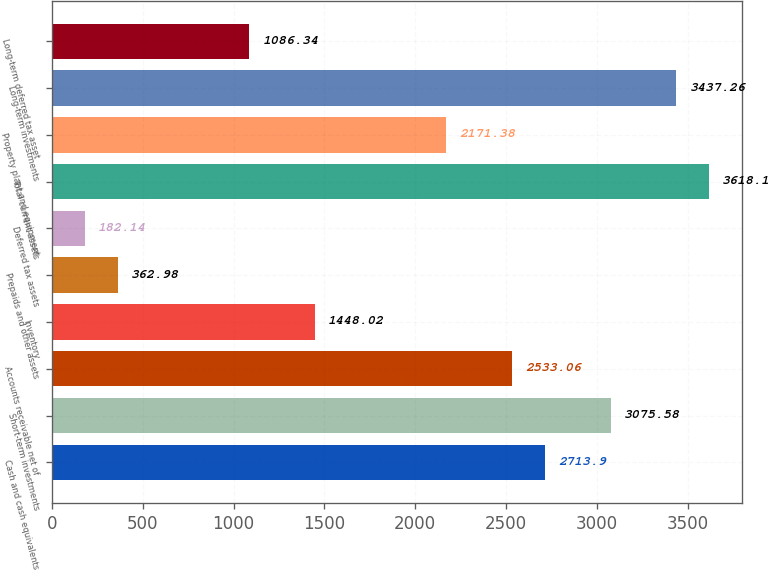<chart> <loc_0><loc_0><loc_500><loc_500><bar_chart><fcel>Cash and cash equivalents<fcel>Short-term investments<fcel>Accounts receivable net of<fcel>Inventory<fcel>Prepaids and other assets<fcel>Deferred tax assets<fcel>Total current assets<fcel>Property plant and equipment<fcel>Long-term investments<fcel>Long-term deferred tax asset<nl><fcel>2713.9<fcel>3075.58<fcel>2533.06<fcel>1448.02<fcel>362.98<fcel>182.14<fcel>3618.1<fcel>2171.38<fcel>3437.26<fcel>1086.34<nl></chart> 